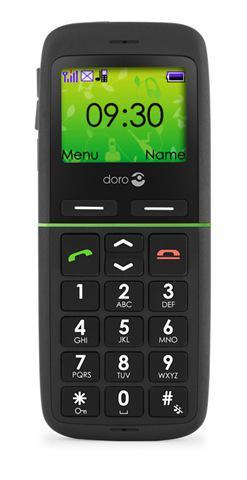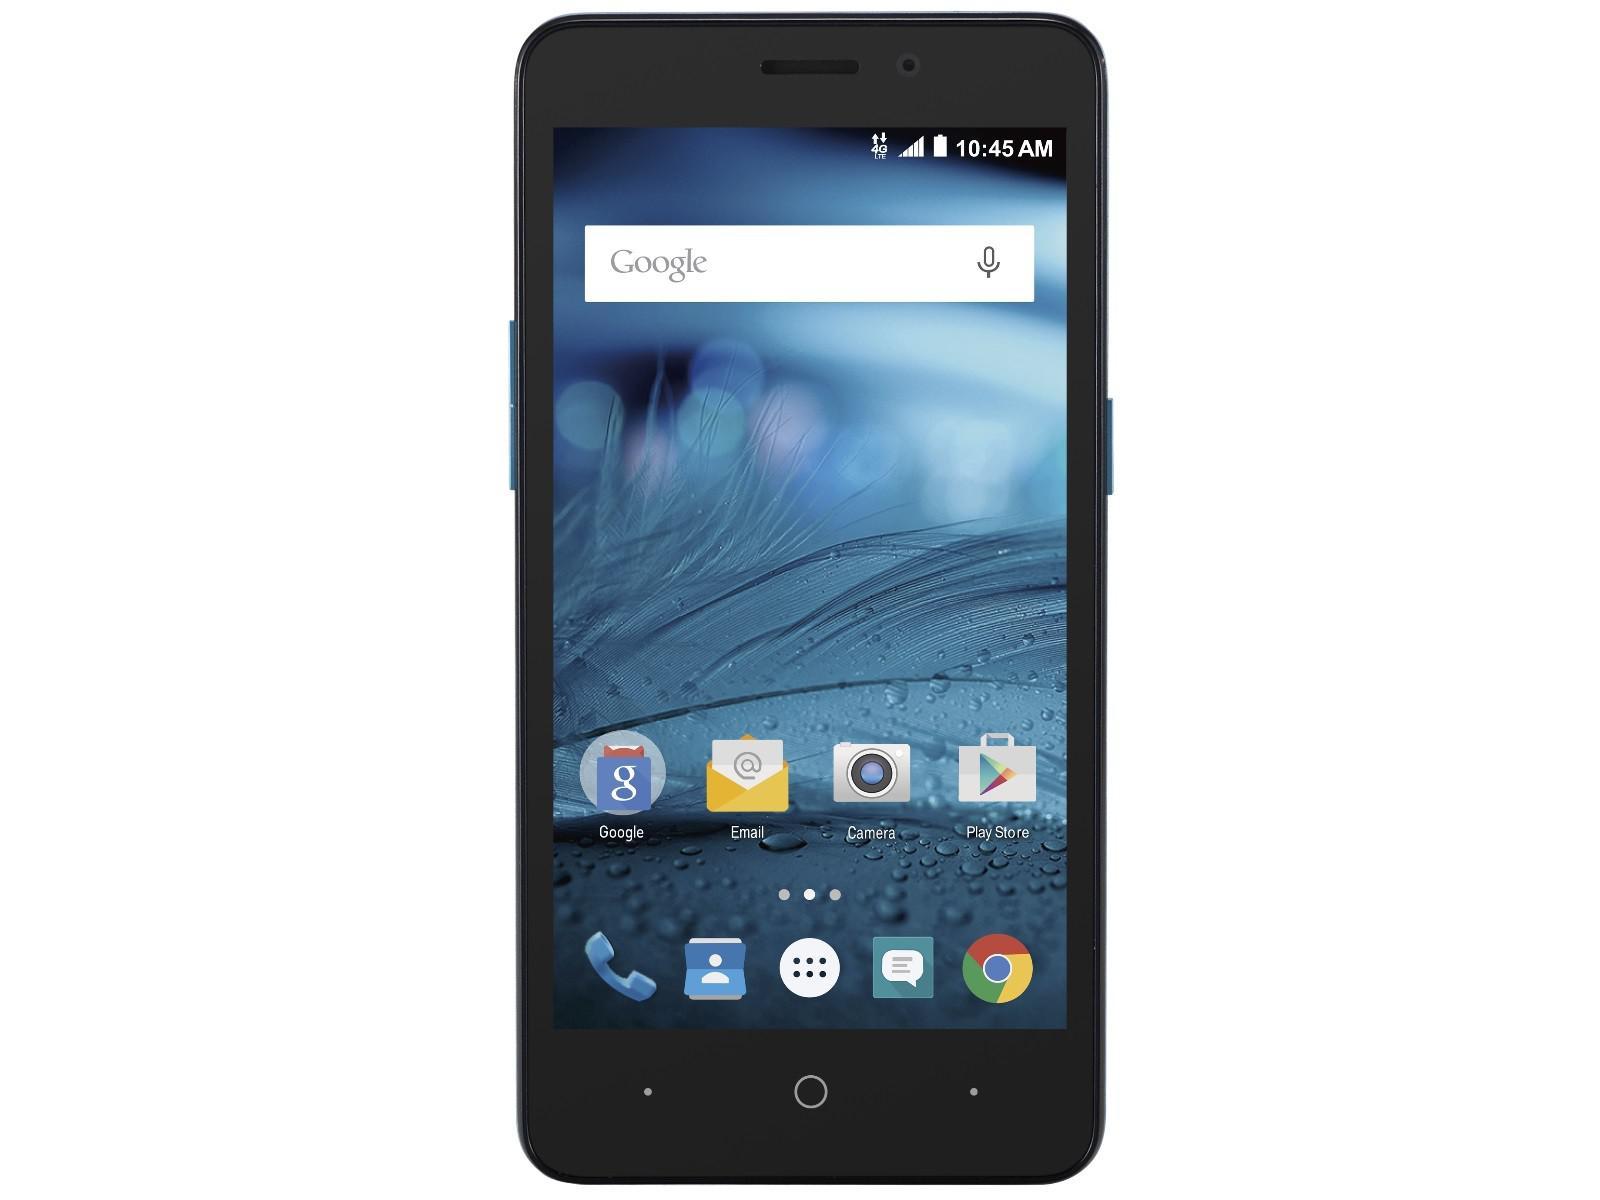The first image is the image on the left, the second image is the image on the right. Evaluate the accuracy of this statement regarding the images: "The cellphone in each image shows the Google search bar on it's home page.". Is it true? Answer yes or no. No. 